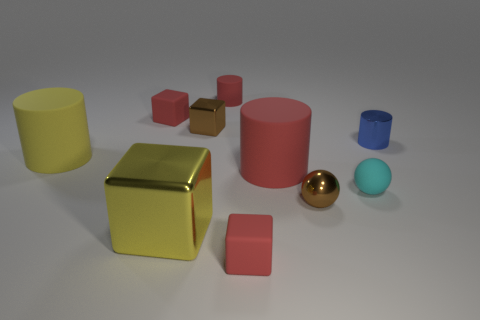How many shiny objects are small cyan objects or small gray balls?
Make the answer very short. 0. What color is the other tiny object that is the same shape as the tiny blue object?
Make the answer very short. Red. How many big matte cylinders have the same color as the large metal thing?
Your response must be concise. 1. There is a matte cube that is in front of the cyan rubber ball; are there any brown blocks that are to the right of it?
Ensure brevity in your answer.  No. What number of cylinders are both on the left side of the metallic cylinder and behind the big red object?
Your answer should be very brief. 2. What number of big yellow objects have the same material as the small red cylinder?
Your response must be concise. 1. There is a brown thing that is to the left of the red rubber block in front of the yellow metallic cube; how big is it?
Keep it short and to the point. Small. Is there a tiny brown thing that has the same shape as the blue metallic thing?
Offer a very short reply. No. There is a yellow object behind the metal sphere; is its size the same as the shiny block that is in front of the metal cylinder?
Your response must be concise. Yes. Is the number of tiny blue things in front of the small blue metallic object less than the number of yellow matte objects that are behind the yellow cylinder?
Keep it short and to the point. No. 